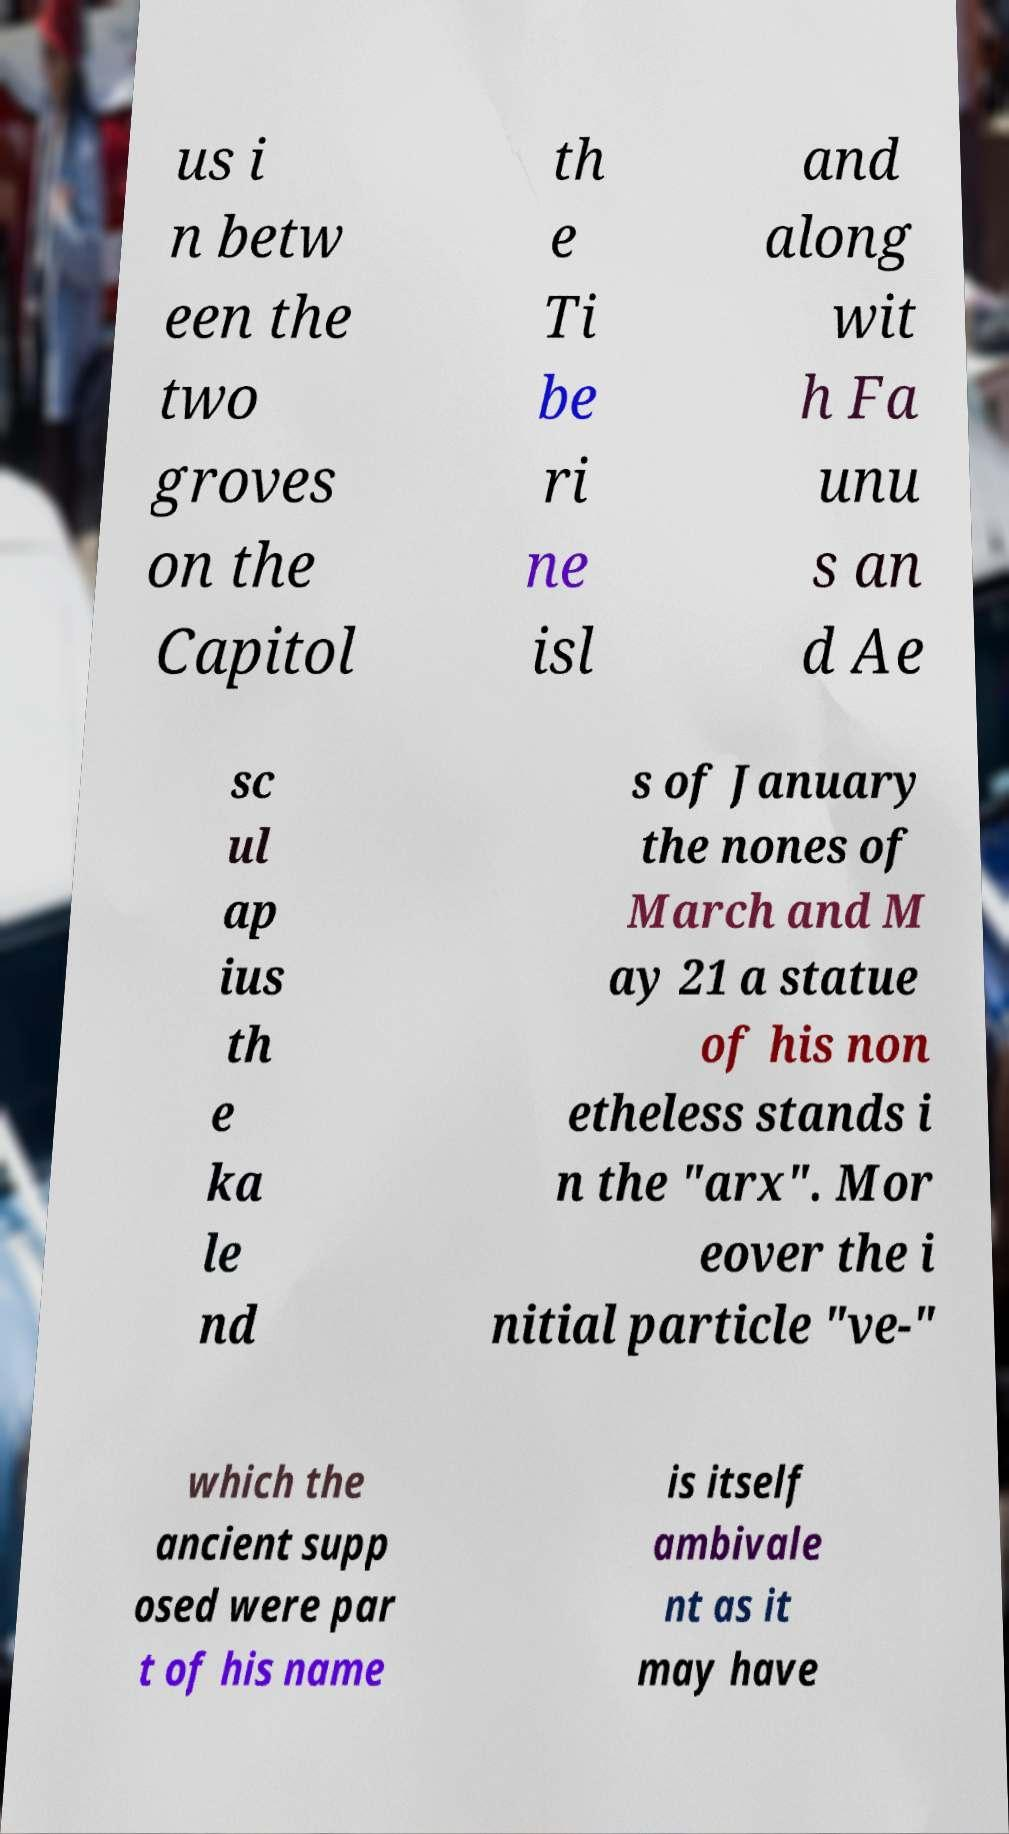Can you accurately transcribe the text from the provided image for me? us i n betw een the two groves on the Capitol th e Ti be ri ne isl and along wit h Fa unu s an d Ae sc ul ap ius th e ka le nd s of January the nones of March and M ay 21 a statue of his non etheless stands i n the "arx". Mor eover the i nitial particle "ve-" which the ancient supp osed were par t of his name is itself ambivale nt as it may have 